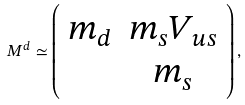<formula> <loc_0><loc_0><loc_500><loc_500>M ^ { d } \simeq \left ( \begin{array} { c c } m _ { d } & m _ { s } V _ { u s } \\ & m _ { s } \end{array} \right ) ,</formula> 